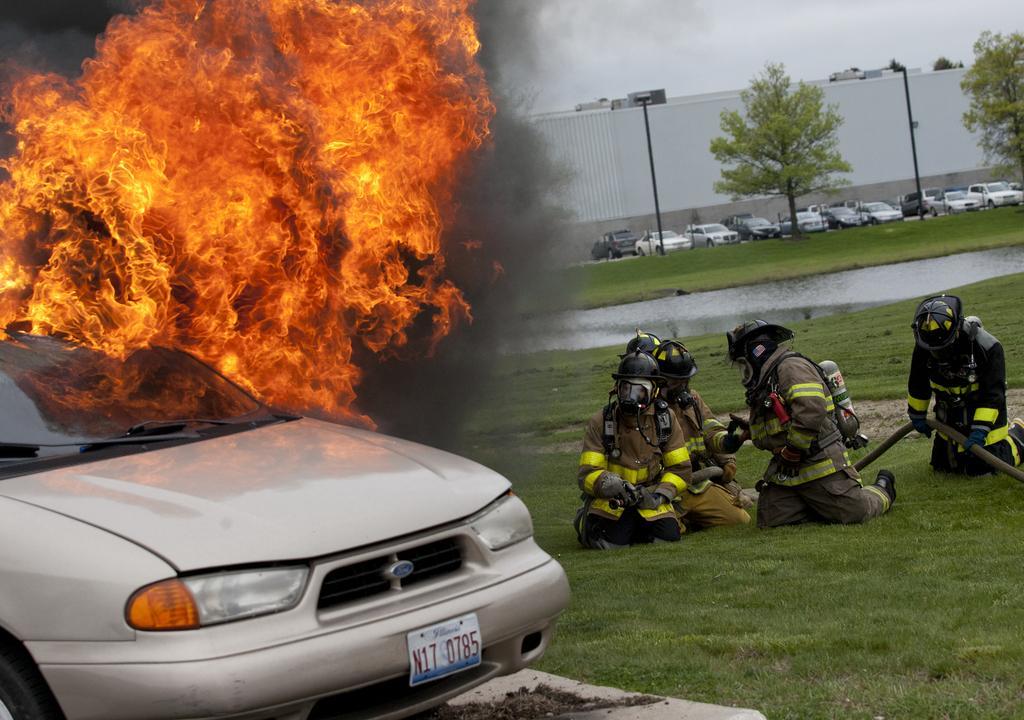How would you summarize this image in a sentence or two? On the left side, we see a white car. Behind that, we see the fire. At the bottom, we see the grass. On the right side, we see the people in the uniform are wearing the helmets and they are holding the fire extinguishers. Behind them, we see the water in the pond. In the background, we see the cars, trees and poles. We see a wall in the background. At the top, we see the sky. 